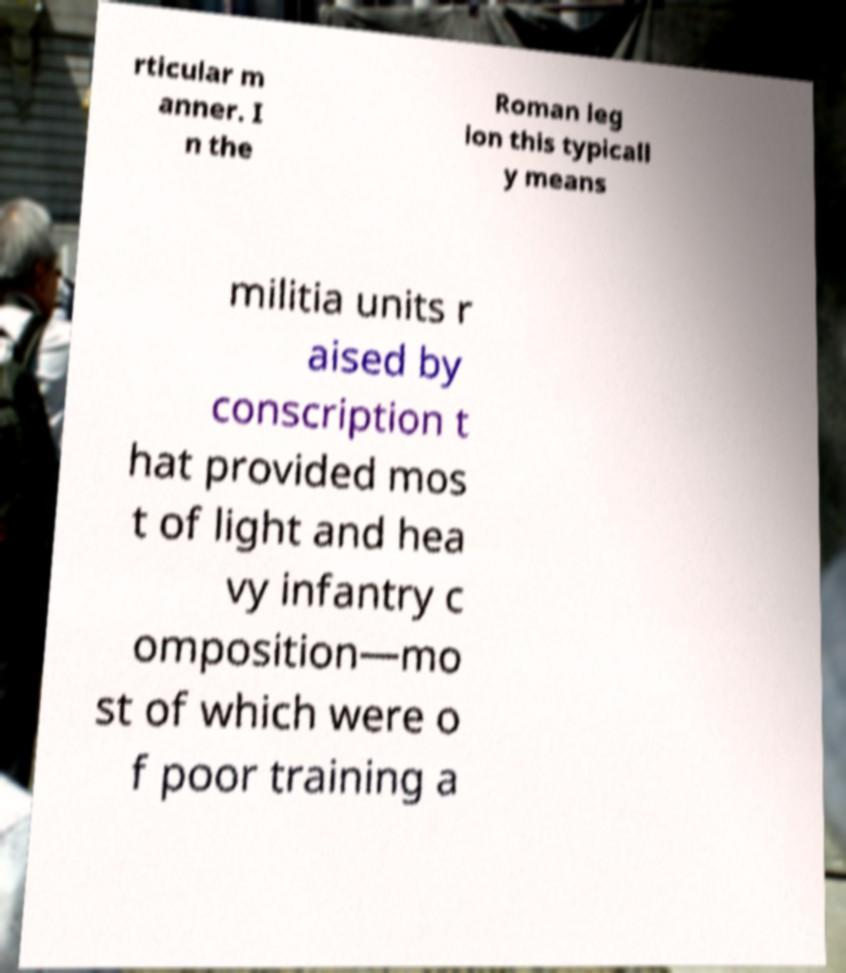What messages or text are displayed in this image? I need them in a readable, typed format. rticular m anner. I n the Roman leg ion this typicall y means militia units r aised by conscription t hat provided mos t of light and hea vy infantry c omposition—mo st of which were o f poor training a 